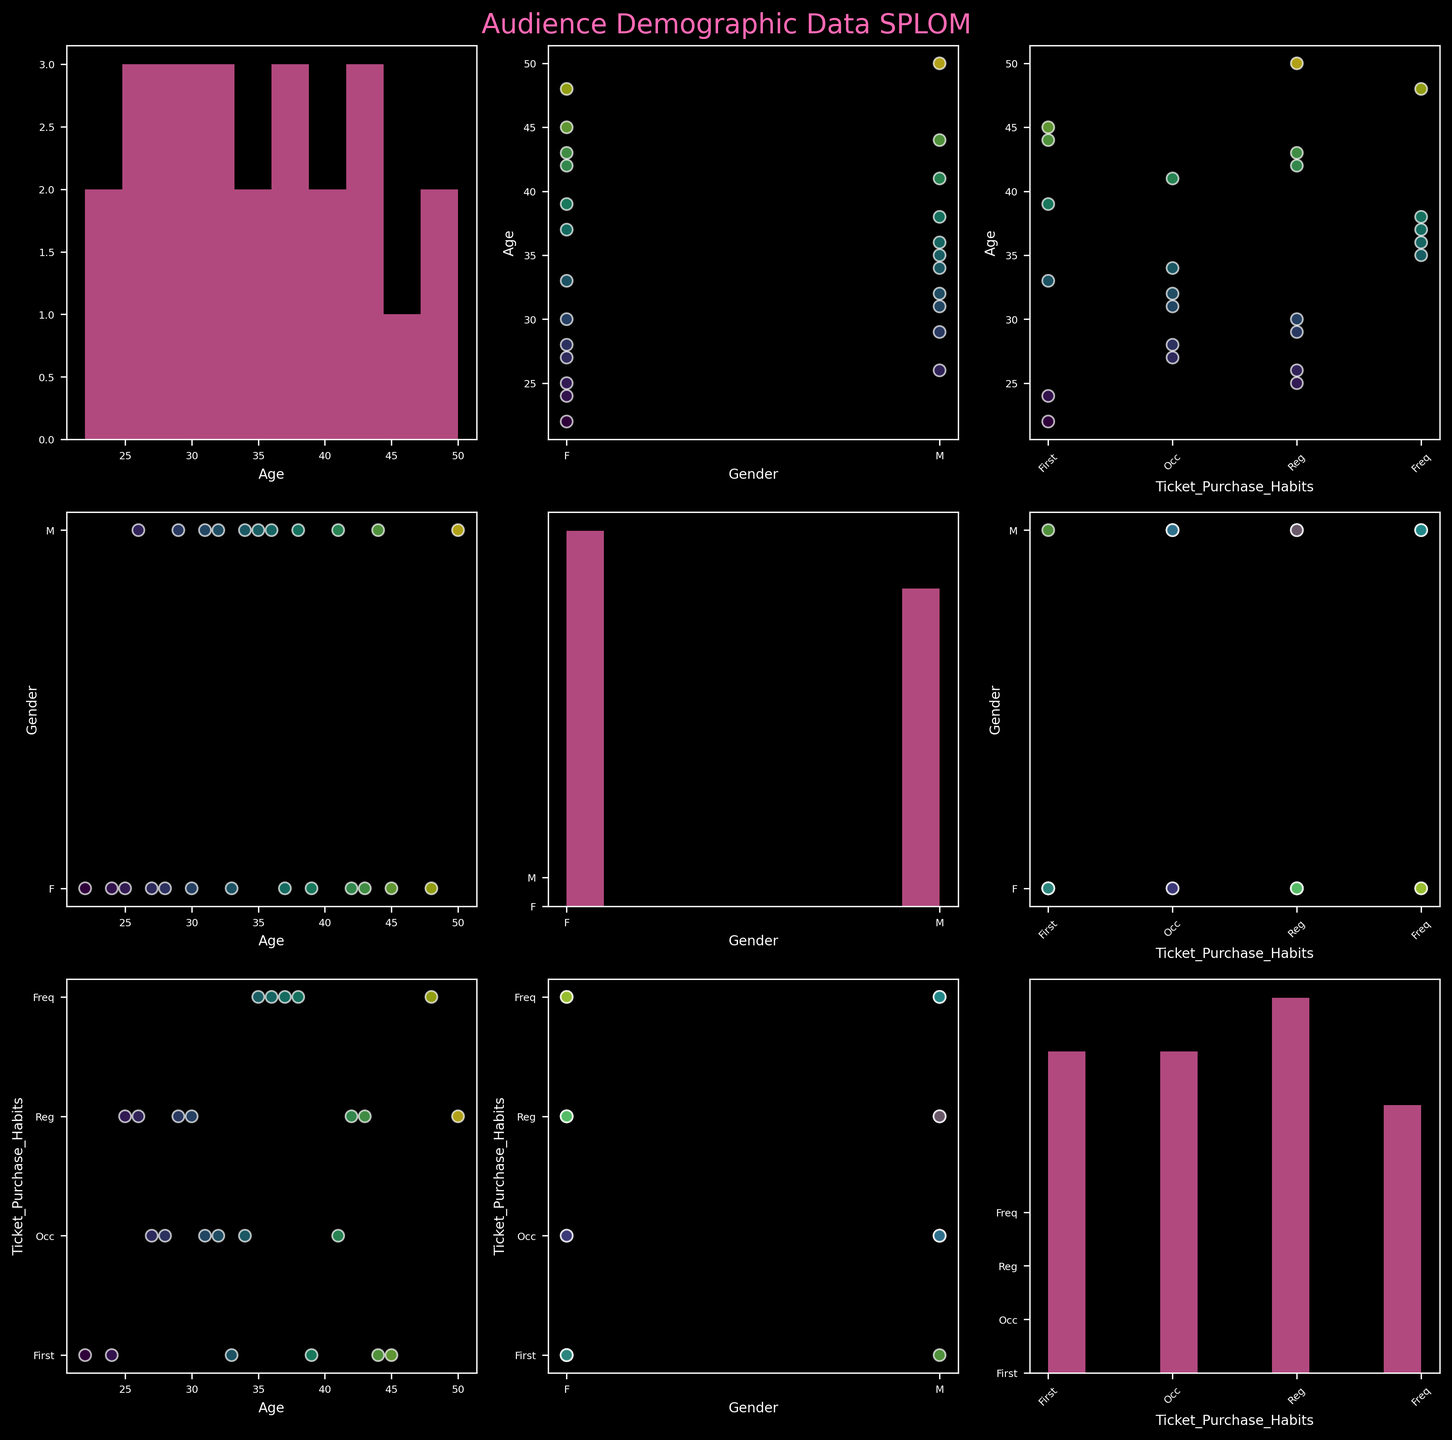What is the title of the plot? The figure clearly shows the title at the top.
Answer: Audience Demographic Data SPLOM What colors are used for the histograms? The histogram bars are colored with a distinctive hue; they are bright and cover various shades to make them stand out.
Answer: Pink Which variables are being compared in the scatter plot matrix? The scatter plot matrix uses the variables labeled on each axis to compare pairs.
Answer: Age, Gender, and Ticket Purchase Habits How are `Gender` values represented in the scatter plot? Each scatter plot axis, as well as the axis labels, show distinct categories for gender.
Answer: F and M What is indicated by the different colors in the scatter plots? The scatter plots use a color gradient which corresponds to the `Age` variable, indicating different age ranges.
Answer: Age Is there any noticeable trend between Age and Ticket Purchase Habits? To observe trends, one would look for a consistent pattern in the correlation between the Age axis labels and the Ticket Purchase Habits axis labels, across multiple scatter plots.
Answer: Younger ages tend to be first-time buyers Do the histograms for each variable show any skewness? By examining the shape of the histogram bars, we notice if the data is not evenly distributed around the mean, indicating skewness.
Answer: Yes, some variables show a right skew Which gender has a broader age spread? Comparing the density of points along the `Age` axis in scatter plots between genders reveals their spread.
Answer: F In terms of ticket purchase frequency, which habit is the least common among the audience? The scatter plot matrix shows ticket purchase habits spread across various categories, and the frequency can be inferred from fewer points.
Answer: First-time How does the frequent ticket purchase habit relate to age? Observing where the `Frequent` category lies along the `Age` axis and how densely data points cluster reveals the relationship.
Answer: More frequent in ages 35-40 